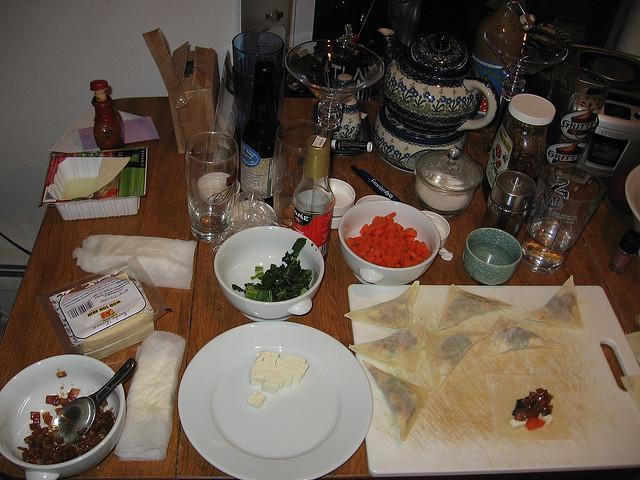How many cups are in the picture?
Give a very brief answer. 5. How many spoons are there?
Give a very brief answer. 1. How many dining tables can you see?
Give a very brief answer. 2. How many bottles are visible?
Give a very brief answer. 3. How many bowls are there?
Give a very brief answer. 4. 